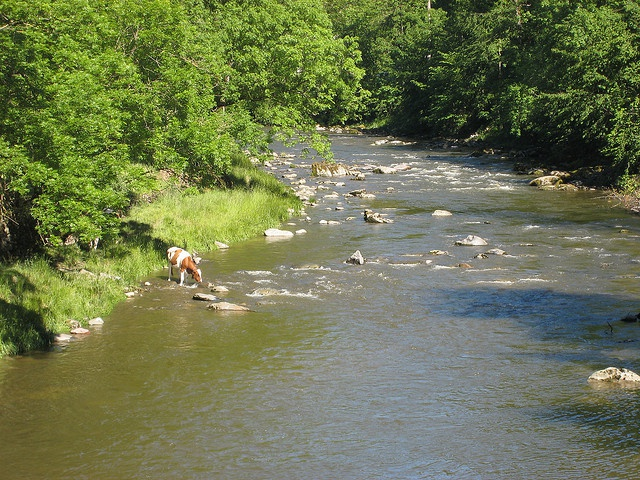Describe the objects in this image and their specific colors. I can see a cow in darkgreen, white, tan, and brown tones in this image. 